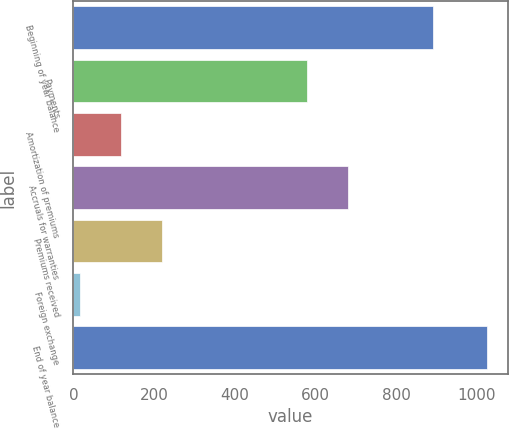<chart> <loc_0><loc_0><loc_500><loc_500><bar_chart><fcel>Beginning of year balance<fcel>Payments<fcel>Amortization of premiums<fcel>Accruals for warranties<fcel>Premiums received<fcel>Foreign exchange<fcel>End of year balance<nl><fcel>892<fcel>580<fcel>117.8<fcel>680.8<fcel>218.6<fcel>17<fcel>1025<nl></chart> 